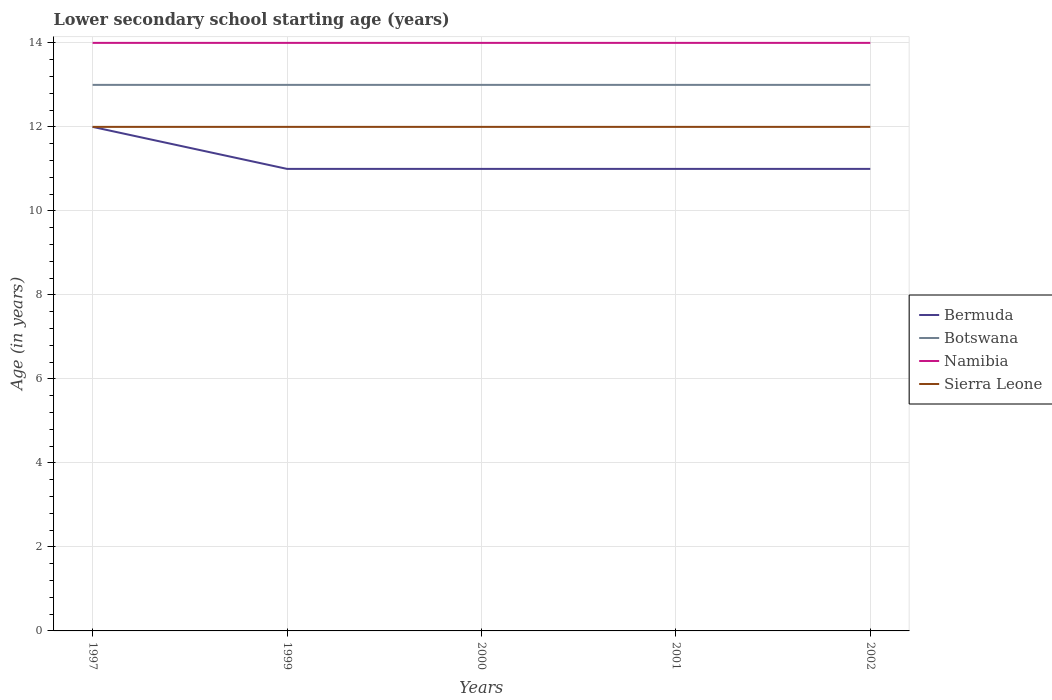How many different coloured lines are there?
Give a very brief answer. 4. Does the line corresponding to Botswana intersect with the line corresponding to Namibia?
Ensure brevity in your answer.  No. In which year was the lower secondary school starting age of children in Namibia maximum?
Keep it short and to the point. 1997. How many lines are there?
Your answer should be compact. 4. Does the graph contain any zero values?
Offer a terse response. No. Where does the legend appear in the graph?
Ensure brevity in your answer.  Center right. How are the legend labels stacked?
Your answer should be very brief. Vertical. What is the title of the graph?
Provide a short and direct response. Lower secondary school starting age (years). What is the label or title of the X-axis?
Provide a short and direct response. Years. What is the label or title of the Y-axis?
Offer a very short reply. Age (in years). What is the Age (in years) in Namibia in 1997?
Your answer should be very brief. 14. What is the Age (in years) of Sierra Leone in 1997?
Keep it short and to the point. 12. What is the Age (in years) in Botswana in 1999?
Give a very brief answer. 13. What is the Age (in years) of Bermuda in 2000?
Your response must be concise. 11. What is the Age (in years) in Botswana in 2001?
Offer a terse response. 13. What is the Age (in years) in Namibia in 2001?
Your answer should be compact. 14. What is the Age (in years) in Sierra Leone in 2001?
Keep it short and to the point. 12. What is the Age (in years) in Bermuda in 2002?
Ensure brevity in your answer.  11. What is the Age (in years) in Namibia in 2002?
Offer a terse response. 14. What is the Age (in years) in Sierra Leone in 2002?
Your answer should be compact. 12. Across all years, what is the maximum Age (in years) in Namibia?
Give a very brief answer. 14. Across all years, what is the minimum Age (in years) of Botswana?
Keep it short and to the point. 13. Across all years, what is the minimum Age (in years) of Namibia?
Give a very brief answer. 14. Across all years, what is the minimum Age (in years) in Sierra Leone?
Provide a short and direct response. 12. What is the total Age (in years) in Bermuda in the graph?
Provide a short and direct response. 56. What is the total Age (in years) of Namibia in the graph?
Offer a terse response. 70. What is the total Age (in years) of Sierra Leone in the graph?
Give a very brief answer. 60. What is the difference between the Age (in years) in Botswana in 1997 and that in 1999?
Your answer should be compact. 0. What is the difference between the Age (in years) of Bermuda in 1997 and that in 2000?
Your response must be concise. 1. What is the difference between the Age (in years) in Bermuda in 1997 and that in 2001?
Offer a very short reply. 1. What is the difference between the Age (in years) in Namibia in 1997 and that in 2001?
Offer a very short reply. 0. What is the difference between the Age (in years) in Sierra Leone in 1997 and that in 2001?
Offer a very short reply. 0. What is the difference between the Age (in years) in Bermuda in 1997 and that in 2002?
Your answer should be very brief. 1. What is the difference between the Age (in years) of Namibia in 1997 and that in 2002?
Offer a very short reply. 0. What is the difference between the Age (in years) of Botswana in 1999 and that in 2001?
Provide a short and direct response. 0. What is the difference between the Age (in years) in Bermuda in 1999 and that in 2002?
Offer a terse response. 0. What is the difference between the Age (in years) of Botswana in 1999 and that in 2002?
Keep it short and to the point. 0. What is the difference between the Age (in years) in Namibia in 1999 and that in 2002?
Your answer should be very brief. 0. What is the difference between the Age (in years) in Sierra Leone in 1999 and that in 2002?
Provide a short and direct response. 0. What is the difference between the Age (in years) in Bermuda in 2000 and that in 2002?
Make the answer very short. 0. What is the difference between the Age (in years) in Botswana in 2000 and that in 2002?
Offer a terse response. 0. What is the difference between the Age (in years) in Namibia in 2000 and that in 2002?
Provide a short and direct response. 0. What is the difference between the Age (in years) in Sierra Leone in 2000 and that in 2002?
Provide a succinct answer. 0. What is the difference between the Age (in years) in Bermuda in 2001 and that in 2002?
Your answer should be very brief. 0. What is the difference between the Age (in years) of Botswana in 2001 and that in 2002?
Make the answer very short. 0. What is the difference between the Age (in years) in Bermuda in 1997 and the Age (in years) in Sierra Leone in 1999?
Your answer should be compact. 0. What is the difference between the Age (in years) of Bermuda in 1997 and the Age (in years) of Botswana in 2000?
Ensure brevity in your answer.  -1. What is the difference between the Age (in years) of Bermuda in 1997 and the Age (in years) of Namibia in 2000?
Your answer should be very brief. -2. What is the difference between the Age (in years) of Bermuda in 1997 and the Age (in years) of Sierra Leone in 2000?
Your answer should be compact. 0. What is the difference between the Age (in years) of Botswana in 1997 and the Age (in years) of Namibia in 2000?
Provide a short and direct response. -1. What is the difference between the Age (in years) in Bermuda in 1997 and the Age (in years) in Botswana in 2001?
Provide a succinct answer. -1. What is the difference between the Age (in years) in Bermuda in 1997 and the Age (in years) in Botswana in 2002?
Provide a short and direct response. -1. What is the difference between the Age (in years) in Botswana in 1997 and the Age (in years) in Namibia in 2002?
Provide a short and direct response. -1. What is the difference between the Age (in years) of Botswana in 1997 and the Age (in years) of Sierra Leone in 2002?
Provide a short and direct response. 1. What is the difference between the Age (in years) of Namibia in 1997 and the Age (in years) of Sierra Leone in 2002?
Offer a very short reply. 2. What is the difference between the Age (in years) in Bermuda in 1999 and the Age (in years) in Botswana in 2000?
Your answer should be compact. -2. What is the difference between the Age (in years) in Bermuda in 1999 and the Age (in years) in Namibia in 2000?
Offer a very short reply. -3. What is the difference between the Age (in years) of Bermuda in 1999 and the Age (in years) of Sierra Leone in 2000?
Make the answer very short. -1. What is the difference between the Age (in years) in Botswana in 1999 and the Age (in years) in Namibia in 2000?
Your answer should be very brief. -1. What is the difference between the Age (in years) of Namibia in 1999 and the Age (in years) of Sierra Leone in 2000?
Your answer should be very brief. 2. What is the difference between the Age (in years) in Bermuda in 1999 and the Age (in years) in Botswana in 2001?
Your response must be concise. -2. What is the difference between the Age (in years) of Bermuda in 1999 and the Age (in years) of Sierra Leone in 2001?
Ensure brevity in your answer.  -1. What is the difference between the Age (in years) in Bermuda in 1999 and the Age (in years) in Namibia in 2002?
Your answer should be very brief. -3. What is the difference between the Age (in years) of Bermuda in 1999 and the Age (in years) of Sierra Leone in 2002?
Make the answer very short. -1. What is the difference between the Age (in years) of Bermuda in 2000 and the Age (in years) of Sierra Leone in 2001?
Offer a very short reply. -1. What is the difference between the Age (in years) of Bermuda in 2000 and the Age (in years) of Sierra Leone in 2002?
Offer a very short reply. -1. What is the difference between the Age (in years) in Botswana in 2000 and the Age (in years) in Namibia in 2002?
Your answer should be compact. -1. What is the difference between the Age (in years) in Namibia in 2000 and the Age (in years) in Sierra Leone in 2002?
Provide a short and direct response. 2. What is the difference between the Age (in years) of Bermuda in 2001 and the Age (in years) of Botswana in 2002?
Provide a short and direct response. -2. What is the difference between the Age (in years) in Bermuda in 2001 and the Age (in years) in Sierra Leone in 2002?
Your answer should be very brief. -1. What is the average Age (in years) of Botswana per year?
Provide a succinct answer. 13. In the year 1997, what is the difference between the Age (in years) in Bermuda and Age (in years) in Sierra Leone?
Offer a very short reply. 0. In the year 1997, what is the difference between the Age (in years) of Botswana and Age (in years) of Sierra Leone?
Your answer should be very brief. 1. In the year 1997, what is the difference between the Age (in years) of Namibia and Age (in years) of Sierra Leone?
Provide a succinct answer. 2. In the year 1999, what is the difference between the Age (in years) of Bermuda and Age (in years) of Namibia?
Your answer should be compact. -3. In the year 1999, what is the difference between the Age (in years) in Bermuda and Age (in years) in Sierra Leone?
Offer a very short reply. -1. In the year 1999, what is the difference between the Age (in years) of Botswana and Age (in years) of Sierra Leone?
Ensure brevity in your answer.  1. In the year 1999, what is the difference between the Age (in years) of Namibia and Age (in years) of Sierra Leone?
Your answer should be very brief. 2. In the year 2000, what is the difference between the Age (in years) of Bermuda and Age (in years) of Botswana?
Keep it short and to the point. -2. In the year 2000, what is the difference between the Age (in years) of Bermuda and Age (in years) of Namibia?
Your answer should be very brief. -3. In the year 2000, what is the difference between the Age (in years) of Namibia and Age (in years) of Sierra Leone?
Your answer should be very brief. 2. In the year 2001, what is the difference between the Age (in years) of Bermuda and Age (in years) of Namibia?
Provide a succinct answer. -3. In the year 2001, what is the difference between the Age (in years) of Bermuda and Age (in years) of Sierra Leone?
Your answer should be very brief. -1. In the year 2001, what is the difference between the Age (in years) of Botswana and Age (in years) of Namibia?
Ensure brevity in your answer.  -1. In the year 2002, what is the difference between the Age (in years) in Bermuda and Age (in years) in Sierra Leone?
Your answer should be very brief. -1. In the year 2002, what is the difference between the Age (in years) of Botswana and Age (in years) of Sierra Leone?
Your response must be concise. 1. What is the ratio of the Age (in years) of Bermuda in 1997 to that in 1999?
Your response must be concise. 1.09. What is the ratio of the Age (in years) of Botswana in 1997 to that in 1999?
Your answer should be very brief. 1. What is the ratio of the Age (in years) in Sierra Leone in 1997 to that in 1999?
Provide a short and direct response. 1. What is the ratio of the Age (in years) of Namibia in 1997 to that in 2000?
Provide a succinct answer. 1. What is the ratio of the Age (in years) of Sierra Leone in 1997 to that in 2001?
Provide a short and direct response. 1. What is the ratio of the Age (in years) of Bermuda in 1997 to that in 2002?
Provide a short and direct response. 1.09. What is the ratio of the Age (in years) of Botswana in 1999 to that in 2000?
Offer a terse response. 1. What is the ratio of the Age (in years) of Sierra Leone in 1999 to that in 2000?
Give a very brief answer. 1. What is the ratio of the Age (in years) in Botswana in 1999 to that in 2001?
Offer a very short reply. 1. What is the ratio of the Age (in years) in Namibia in 1999 to that in 2001?
Offer a very short reply. 1. What is the ratio of the Age (in years) in Sierra Leone in 1999 to that in 2001?
Offer a very short reply. 1. What is the ratio of the Age (in years) of Bermuda in 1999 to that in 2002?
Ensure brevity in your answer.  1. What is the ratio of the Age (in years) of Botswana in 2000 to that in 2001?
Your response must be concise. 1. What is the ratio of the Age (in years) of Namibia in 2000 to that in 2001?
Your answer should be very brief. 1. What is the ratio of the Age (in years) of Bermuda in 2000 to that in 2002?
Offer a very short reply. 1. What is the ratio of the Age (in years) of Botswana in 2000 to that in 2002?
Give a very brief answer. 1. What is the ratio of the Age (in years) of Sierra Leone in 2000 to that in 2002?
Provide a succinct answer. 1. What is the ratio of the Age (in years) of Bermuda in 2001 to that in 2002?
Your answer should be compact. 1. What is the ratio of the Age (in years) in Namibia in 2001 to that in 2002?
Provide a succinct answer. 1. What is the ratio of the Age (in years) of Sierra Leone in 2001 to that in 2002?
Your response must be concise. 1. What is the difference between the highest and the second highest Age (in years) in Botswana?
Ensure brevity in your answer.  0. What is the difference between the highest and the second highest Age (in years) of Namibia?
Your response must be concise. 0. What is the difference between the highest and the second highest Age (in years) of Sierra Leone?
Offer a terse response. 0. What is the difference between the highest and the lowest Age (in years) in Bermuda?
Provide a succinct answer. 1. What is the difference between the highest and the lowest Age (in years) of Botswana?
Make the answer very short. 0. What is the difference between the highest and the lowest Age (in years) in Namibia?
Your answer should be compact. 0. What is the difference between the highest and the lowest Age (in years) of Sierra Leone?
Keep it short and to the point. 0. 